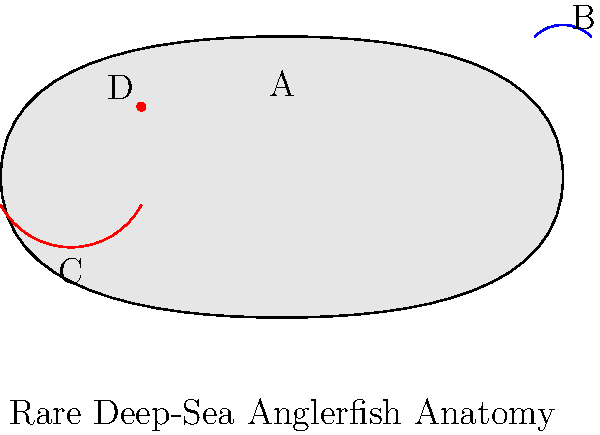Identifiera den struktur som är märkt med "B" i diagrammet av en sällsynt djuphavsmartfisk. Vilken funktion har denna struktur, och hur är den anpassad för fiskens levnadssätt i den mörka djuphavsmiljön? För att besvara denna fråga, låt oss gå igenom djuphavsmartfiskens anatomi steg för steg:

1. Strukturen märkt med "B" är fiskens bioluminescenta lure, eller "esca".

2. Funktioner av luren:
   a) Lockar byten: Den ljusemitterande luren fungerar som en lockbete för att attrahera byten i den mörka djuphavsmiljön.
   b) Kommunikation: Kan också användas för att kommunicera med andra martfiskar, särskilt under parningssäsongen.

3. Anpassningar till djuphavsmiljön:
   a) Bioluminescens: Innehåller ljusproducerande bakterier som ger ett svagt sken i mörkret.
   b) Flexibilitet: Luren är ofta fäst vid en förlängd fena, vilket ger fisken möjlighet att manövrera den för optimal placering.
   c) Energieffektivitet: Ljusproduktionen är energisnål, vilket är viktigt i en miljö med begränsade resurser.

4. Evolutionär betydelse:
   Denna unika anpassning har gjort det möjligt för martfiskar att utnyttja en ekologisk nisch i djuphavet där få andra predatorer kan jaga effektivt.

Sammanfattningsvis är strukturen "B" en bioluminescent lure som är avgörande för martfiskens överlevnad och jaktframgång i den mörka djuphavsmiljön.
Answer: Bioluminescent lure (esca) 